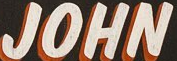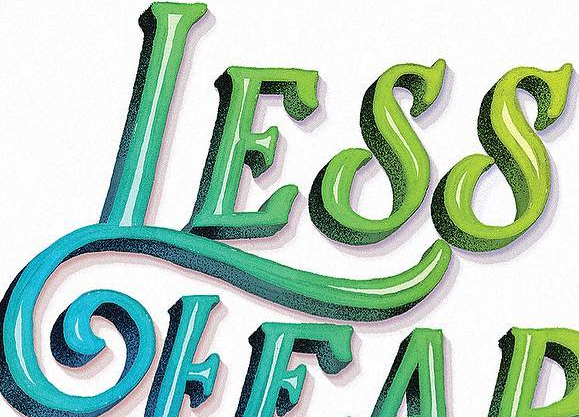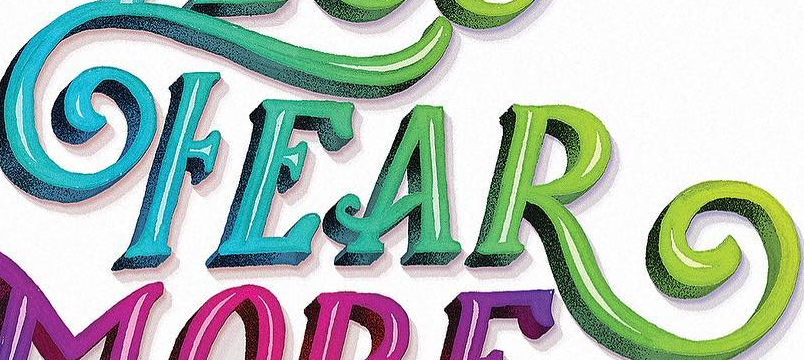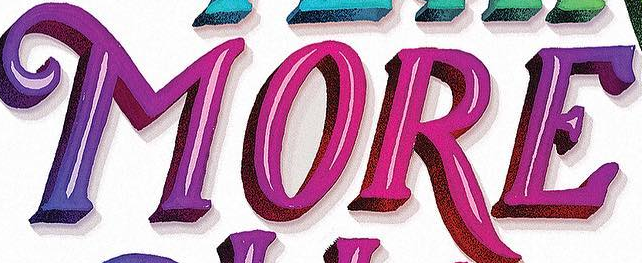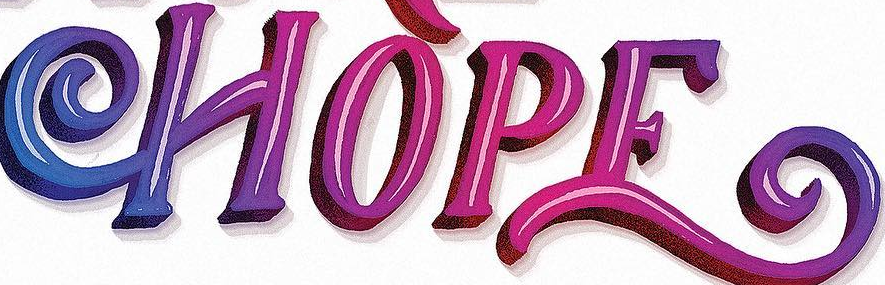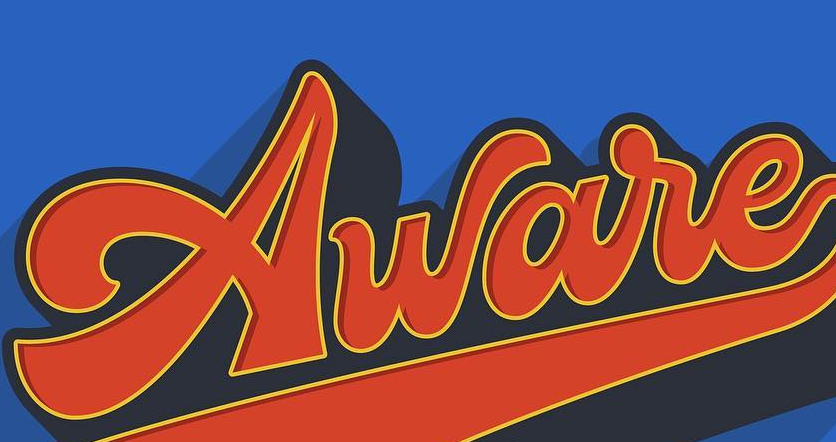What text is displayed in these images sequentially, separated by a semicolon? JOHN; LESS; FEAR; MORE; HOPE; Aware 